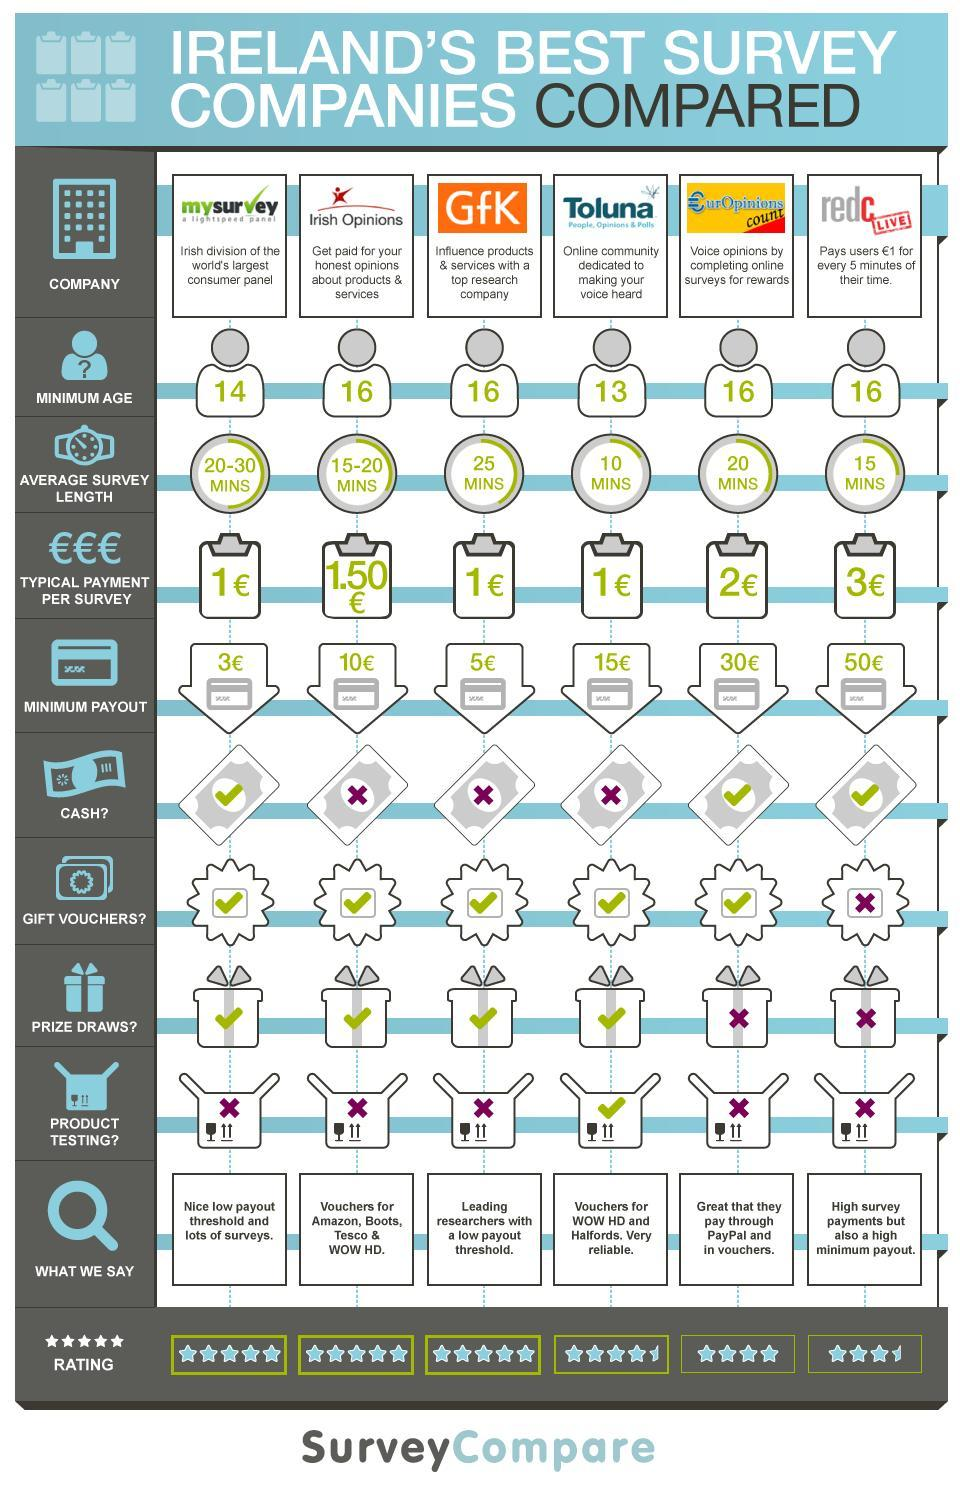What is the rating of the survey conducted by the "Europinions count" company?
Answer the question with a short phrase. 4 Which is the Survey company that do not provide Gift vouchers? redc live Which is the Survey company that gives Amazon vouchers? Irish Opinions How much time it takes to complete the survey of redc live? 15 mins How much the company "Irish Opinions" pays in euro for each of its survey? 1.50 What is the minimum age required to attend the survey of GfK? 16 Which company has the world's biggest consumer panel? mysurvey Which Irish survey company pays through PayPal and vouchers? Europinions count How much the company "redc live" pays in euro for each of its survey? 3 Which are the Survey companies that do not payoff in Cash? Irish Opinions, GfK, Toluna 